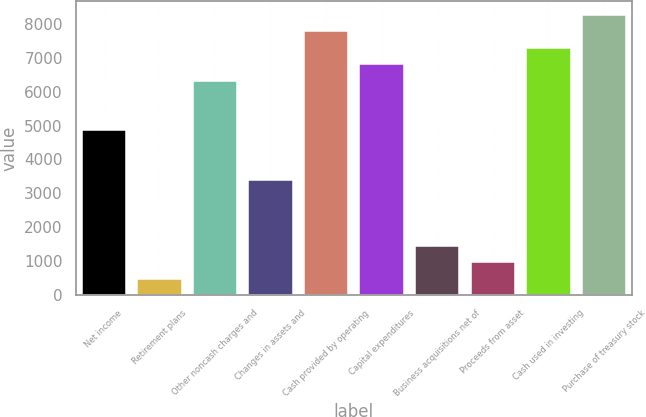Convert chart to OTSL. <chart><loc_0><loc_0><loc_500><loc_500><bar_chart><fcel>Net income<fcel>Retirement plans<fcel>Other noncash charges and<fcel>Changes in assets and<fcel>Cash provided by operating<fcel>Capital expenditures<fcel>Business acquisitions net of<fcel>Proceeds from asset<fcel>Cash used in investing<fcel>Purchase of treasury stock<nl><fcel>4857<fcel>488.4<fcel>6313.2<fcel>3400.8<fcel>7769.4<fcel>6798.6<fcel>1459.2<fcel>973.8<fcel>7284<fcel>8254.8<nl></chart> 